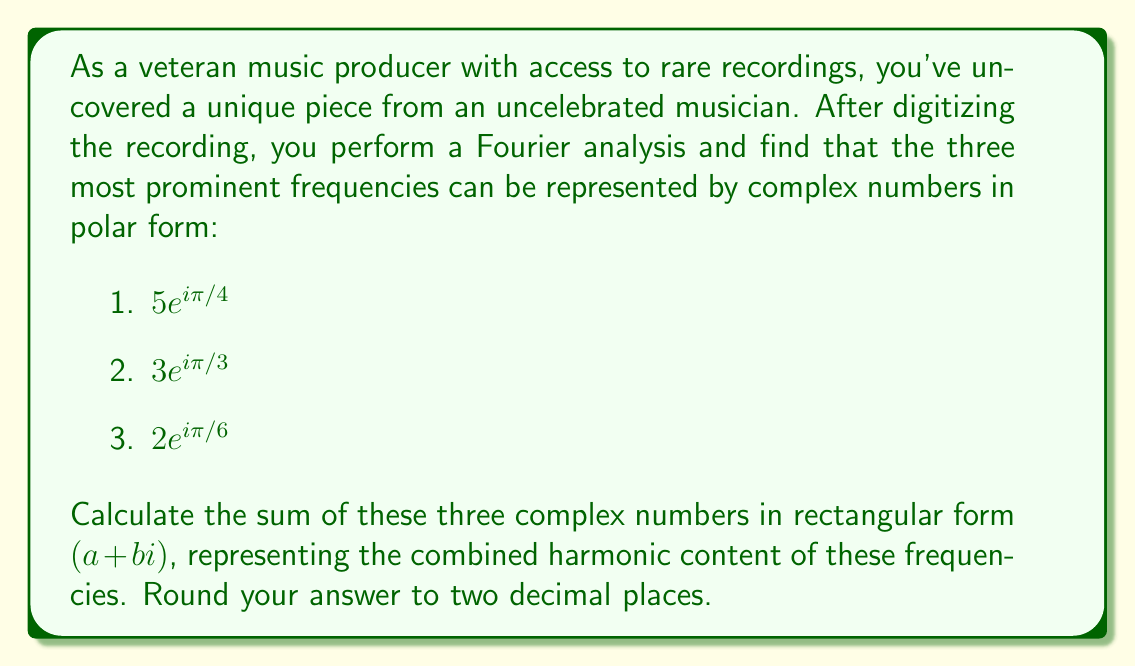Help me with this question. To solve this problem, we need to convert each complex number from polar form to rectangular form and then add them together. Let's go through this step-by-step:

1. Convert $5e^{i\pi/4}$ to rectangular form:
   $a_1 = 5\cos(\pi/4) = 5\cdot\frac{\sqrt{2}}{2} = \frac{5\sqrt{2}}{2}$
   $b_1 = 5\sin(\pi/4) = 5\cdot\frac{\sqrt{2}}{2} = \frac{5\sqrt{2}}{2}$

2. Convert $3e^{i\pi/3}$ to rectangular form:
   $a_2 = 3\cos(\pi/3) = 3\cdot\frac{1}{2} = \frac{3}{2}$
   $b_2 = 3\sin(\pi/3) = 3\cdot\frac{\sqrt{3}}{2} = \frac{3\sqrt{3}}{2}$

3. Convert $2e^{i\pi/6}$ to rectangular form:
   $a_3 = 2\cos(\pi/6) = 2\cdot\frac{\sqrt{3}}{2} = \sqrt{3}$
   $b_3 = 2\sin(\pi/6) = 2\cdot\frac{1}{2} = 1$

Now, we sum the real and imaginary parts separately:

Real part: $a = a_1 + a_2 + a_3 = \frac{5\sqrt{2}}{2} + \frac{3}{2} + \sqrt{3}$

Imaginary part: $b = b_1 + b_2 + b_3 = \frac{5\sqrt{2}}{2} + \frac{3\sqrt{3}}{2} + 1$

To simplify and calculate the final result:

$a = \frac{5\sqrt{2}}{2} + \frac{3}{2} + \sqrt{3} \approx 3.54 + 1.50 + 1.73 \approx 6.77$

$b = \frac{5\sqrt{2}}{2} + \frac{3\sqrt{3}}{2} + 1 \approx 3.54 + 2.60 + 1.00 \approx 7.14$

Rounding to two decimal places, we get $a \approx 6.77$ and $b \approx 7.14$.
Answer: $6.77 + 7.14i$ 